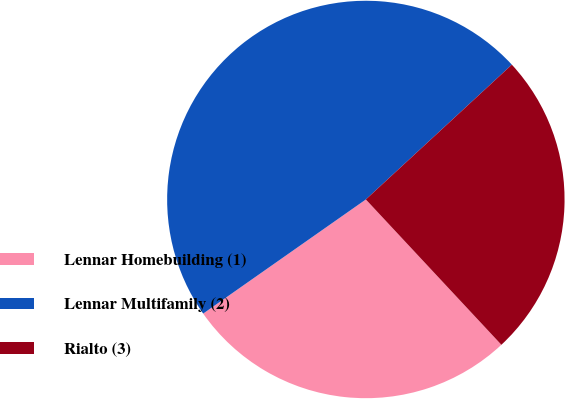Convert chart to OTSL. <chart><loc_0><loc_0><loc_500><loc_500><pie_chart><fcel>Lennar Homebuilding (1)<fcel>Lennar Multifamily (2)<fcel>Rialto (3)<nl><fcel>27.21%<fcel>47.87%<fcel>24.92%<nl></chart> 